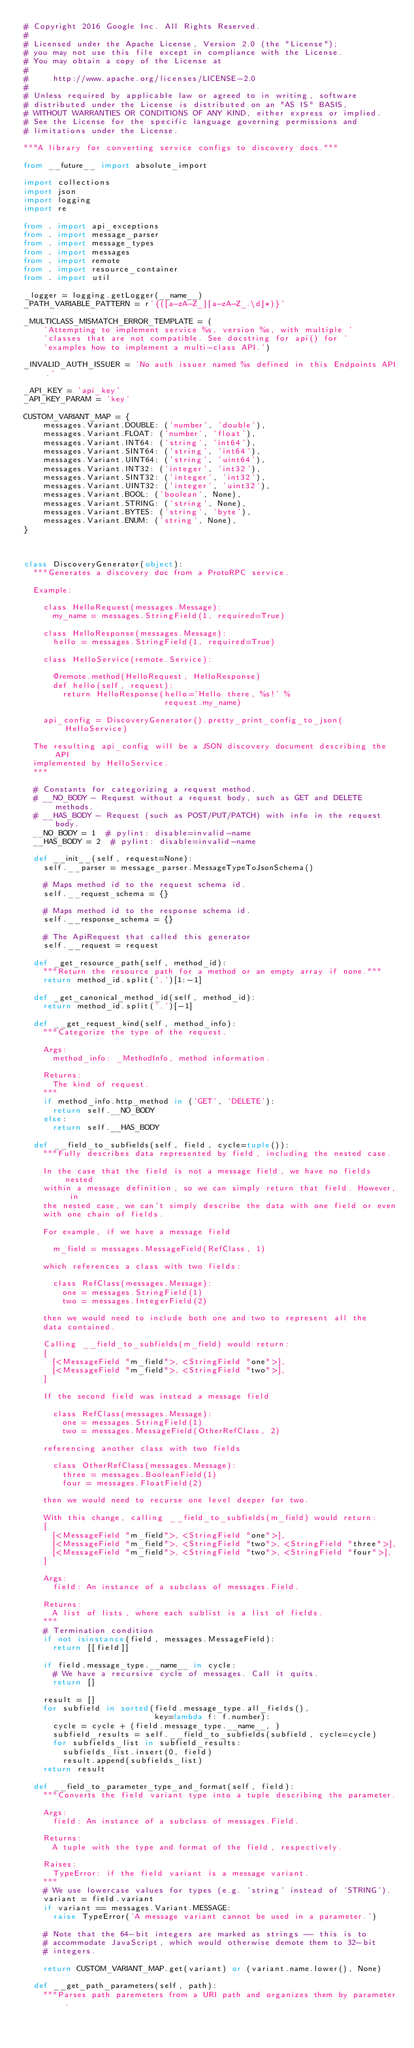Convert code to text. <code><loc_0><loc_0><loc_500><loc_500><_Python_># Copyright 2016 Google Inc. All Rights Reserved.
#
# Licensed under the Apache License, Version 2.0 (the "License");
# you may not use this file except in compliance with the License.
# You may obtain a copy of the License at
#
#     http://www.apache.org/licenses/LICENSE-2.0
#
# Unless required by applicable law or agreed to in writing, software
# distributed under the License is distributed on an "AS IS" BASIS,
# WITHOUT WARRANTIES OR CONDITIONS OF ANY KIND, either express or implied.
# See the License for the specific language governing permissions and
# limitations under the License.

"""A library for converting service configs to discovery docs."""

from __future__ import absolute_import

import collections
import json
import logging
import re

from . import api_exceptions
from . import message_parser
from . import message_types
from . import messages
from . import remote
from . import resource_container
from . import util

_logger = logging.getLogger(__name__)
_PATH_VARIABLE_PATTERN = r'{([a-zA-Z_][a-zA-Z_.\d]*)}'

_MULTICLASS_MISMATCH_ERROR_TEMPLATE = (
    'Attempting to implement service %s, version %s, with multiple '
    'classes that are not compatible. See docstring for api() for '
    'examples how to implement a multi-class API.')

_INVALID_AUTH_ISSUER = 'No auth issuer named %s defined in this Endpoints API.'

_API_KEY = 'api_key'
_API_KEY_PARAM = 'key'

CUSTOM_VARIANT_MAP = {
    messages.Variant.DOUBLE: ('number', 'double'),
    messages.Variant.FLOAT: ('number', 'float'),
    messages.Variant.INT64: ('string', 'int64'),
    messages.Variant.SINT64: ('string', 'int64'),
    messages.Variant.UINT64: ('string', 'uint64'),
    messages.Variant.INT32: ('integer', 'int32'),
    messages.Variant.SINT32: ('integer', 'int32'),
    messages.Variant.UINT32: ('integer', 'uint32'),
    messages.Variant.BOOL: ('boolean', None),
    messages.Variant.STRING: ('string', None),
    messages.Variant.BYTES: ('string', 'byte'),
    messages.Variant.ENUM: ('string', None),
}



class DiscoveryGenerator(object):
  """Generates a discovery doc from a ProtoRPC service.

  Example:

    class HelloRequest(messages.Message):
      my_name = messages.StringField(1, required=True)

    class HelloResponse(messages.Message):
      hello = messages.StringField(1, required=True)

    class HelloService(remote.Service):

      @remote.method(HelloRequest, HelloResponse)
      def hello(self, request):
        return HelloResponse(hello='Hello there, %s!' %
                             request.my_name)

    api_config = DiscoveryGenerator().pretty_print_config_to_json(HelloService)

  The resulting api_config will be a JSON discovery document describing the API
  implemented by HelloService.
  """

  # Constants for categorizing a request method.
  # __NO_BODY - Request without a request body, such as GET and DELETE methods.
  # __HAS_BODY - Request (such as POST/PUT/PATCH) with info in the request body.
  __NO_BODY = 1  # pylint: disable=invalid-name
  __HAS_BODY = 2  # pylint: disable=invalid-name

  def __init__(self, request=None):
    self.__parser = message_parser.MessageTypeToJsonSchema()

    # Maps method id to the request schema id.
    self.__request_schema = {}

    # Maps method id to the response schema id.
    self.__response_schema = {}

    # The ApiRequest that called this generator
    self.__request = request

  def _get_resource_path(self, method_id):
    """Return the resource path for a method or an empty array if none."""
    return method_id.split('.')[1:-1]

  def _get_canonical_method_id(self, method_id):
    return method_id.split('.')[-1]

  def __get_request_kind(self, method_info):
    """Categorize the type of the request.

    Args:
      method_info: _MethodInfo, method information.

    Returns:
      The kind of request.
    """
    if method_info.http_method in ('GET', 'DELETE'):
      return self.__NO_BODY
    else:
      return self.__HAS_BODY

  def __field_to_subfields(self, field, cycle=tuple()):
    """Fully describes data represented by field, including the nested case.

    In the case that the field is not a message field, we have no fields nested
    within a message definition, so we can simply return that field. However, in
    the nested case, we can't simply describe the data with one field or even
    with one chain of fields.

    For example, if we have a message field

      m_field = messages.MessageField(RefClass, 1)

    which references a class with two fields:

      class RefClass(messages.Message):
        one = messages.StringField(1)
        two = messages.IntegerField(2)

    then we would need to include both one and two to represent all the
    data contained.

    Calling __field_to_subfields(m_field) would return:
    [
      [<MessageField "m_field">, <StringField "one">],
      [<MessageField "m_field">, <StringField "two">],
    ]

    If the second field was instead a message field

      class RefClass(messages.Message):
        one = messages.StringField(1)
        two = messages.MessageField(OtherRefClass, 2)

    referencing another class with two fields

      class OtherRefClass(messages.Message):
        three = messages.BooleanField(1)
        four = messages.FloatField(2)

    then we would need to recurse one level deeper for two.

    With this change, calling __field_to_subfields(m_field) would return:
    [
      [<MessageField "m_field">, <StringField "one">],
      [<MessageField "m_field">, <StringField "two">, <StringField "three">],
      [<MessageField "m_field">, <StringField "two">, <StringField "four">],
    ]

    Args:
      field: An instance of a subclass of messages.Field.

    Returns:
      A list of lists, where each sublist is a list of fields.
    """
    # Termination condition
    if not isinstance(field, messages.MessageField):
      return [[field]]

    if field.message_type.__name__ in cycle:
      # We have a recursive cycle of messages. Call it quits.
      return []

    result = []
    for subfield in sorted(field.message_type.all_fields(),
                           key=lambda f: f.number):
      cycle = cycle + (field.message_type.__name__, )
      subfield_results = self.__field_to_subfields(subfield, cycle=cycle)
      for subfields_list in subfield_results:
        subfields_list.insert(0, field)
        result.append(subfields_list)
    return result

  def __field_to_parameter_type_and_format(self, field):
    """Converts the field variant type into a tuple describing the parameter.

    Args:
      field: An instance of a subclass of messages.Field.

    Returns:
      A tuple with the type and format of the field, respectively.

    Raises:
      TypeError: if the field variant is a message variant.
    """
    # We use lowercase values for types (e.g. 'string' instead of 'STRING').
    variant = field.variant
    if variant == messages.Variant.MESSAGE:
      raise TypeError('A message variant cannot be used in a parameter.')

    # Note that the 64-bit integers are marked as strings -- this is to
    # accommodate JavaScript, which would otherwise demote them to 32-bit
    # integers.

    return CUSTOM_VARIANT_MAP.get(variant) or (variant.name.lower(), None)

  def __get_path_parameters(self, path):
    """Parses path paremeters from a URI path and organizes them by parameter.
</code> 